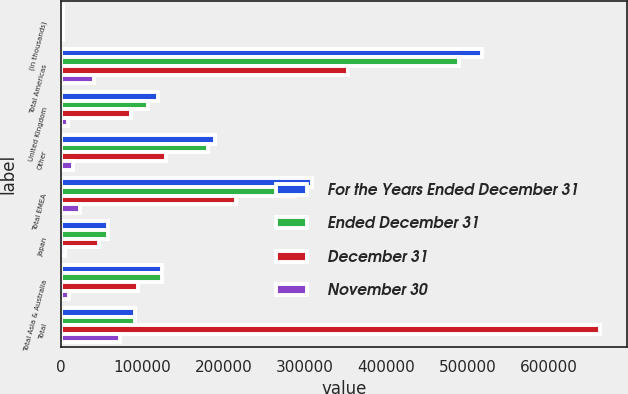<chart> <loc_0><loc_0><loc_500><loc_500><stacked_bar_chart><ecel><fcel>(in thousands)<fcel>Total Americas<fcel>United Kingdom<fcel>Other<fcel>Total EMEA<fcel>Japan<fcel>Total Asia & Australia<fcel>Total<nl><fcel>For the Years Ended December 31<fcel>2012<fcel>517532<fcel>118827<fcel>189465<fcel>308292<fcel>57419<fcel>124317<fcel>90324<nl><fcel>Ended December 31<fcel>2011<fcel>489779<fcel>106648<fcel>180600<fcel>287248<fcel>58023<fcel>123914<fcel>90324<nl><fcel>December 31<fcel>2010<fcel>353319<fcel>86136<fcel>128934<fcel>215070<fcel>46872<fcel>94512<fcel>662901<nl><fcel>November 30<fcel>2010<fcel>40465<fcel>8950<fcel>13917<fcel>22867<fcel>4358<fcel>9192<fcel>72524<nl></chart> 